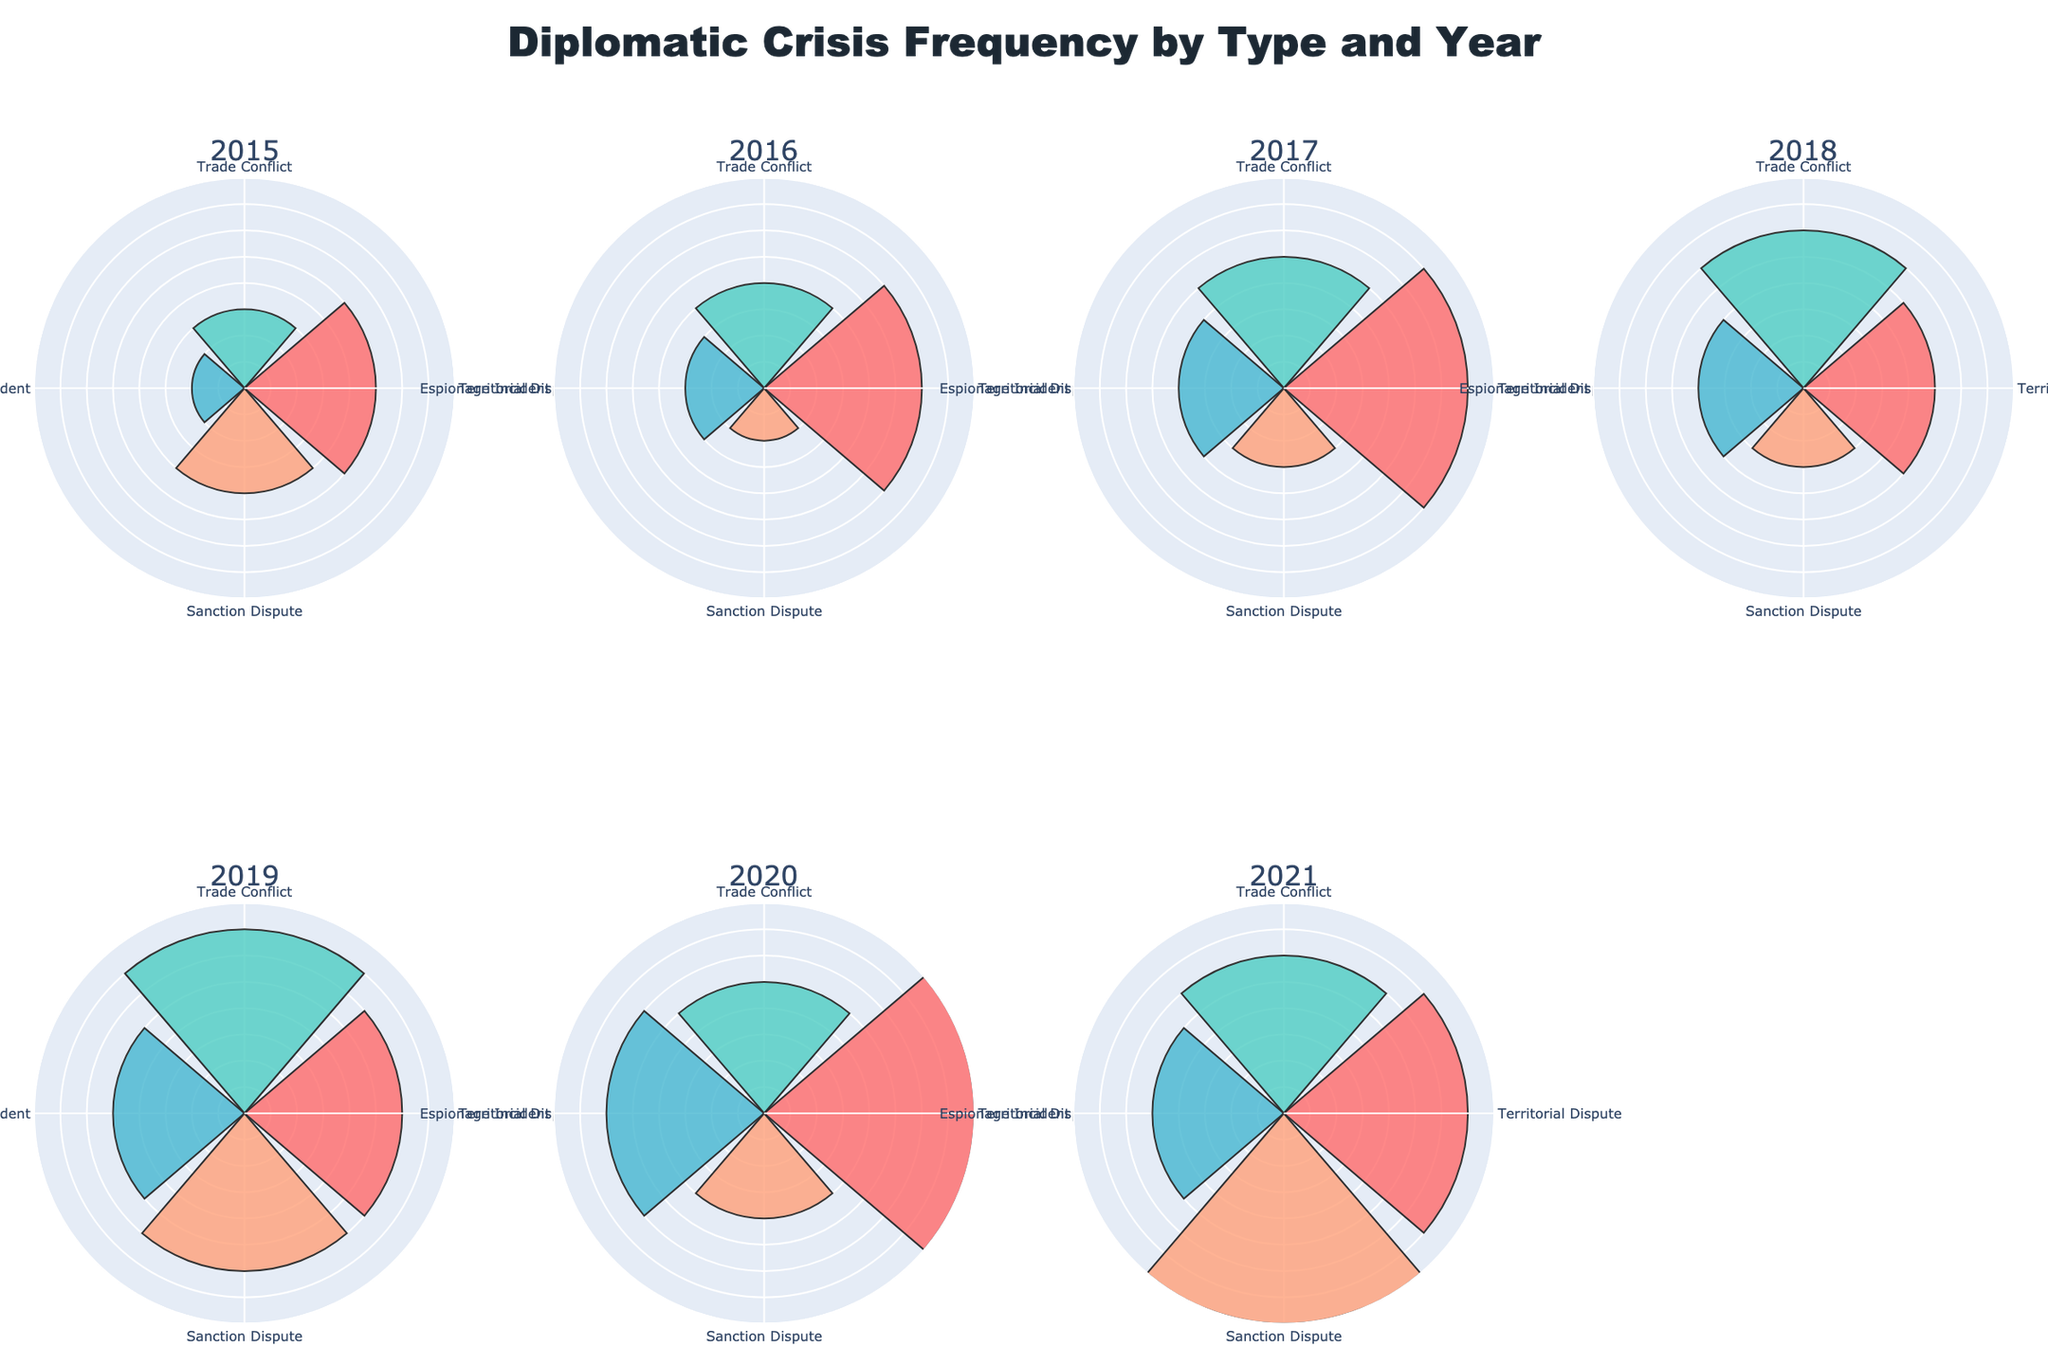What's the title of the figure? The title is prominently displayed at the top of the figure. It summarises what the figure represents.
Answer: Diplomatic Crisis Frequency by Type and Year How many subplots are present in the figure? The figure title suggests it shows data for multiple years, and the plot layout indicates a matrix of subplots.
Answer: 8 Which year had the highest frequency of Territorial Disputes? By examining the size of the bars under "Territorial Dispute" category across all years, the highest bar indicates the maximum frequency.
Answer: 2020 Which type of crisis had the lowest frequency in 2017? Look at the subplot for 2017 and compare the lengths of the bars for different crisis types to find the shortest.
Answer: Sanction Dispute Compare the frequency of Trade Conflicts between 2016 and 2018. Which year had a higher frequency? Locate the subplots for 2016 and 2018, and compare the bars under "Trade Conflict". 2018 has a higher bar visually.
Answer: 2018 In which year did Espionage Incidents increase compared to the previous year? Track the bars for "Espionage Incident" across consecutive subplots and identify years where the bar height increases.
Answer: Multiple years can be identified, but 2018 to 2019 is one instance What's the average frequency of Trade Conflicts from 2015 to 2017? Sum the bar heights for "Trade Conflict" from 2015, 2016, and 2017, then divide by 3. Calculation: (3 + 4 + 5) / 3 = 12 / 3.
Answer: 4 Which type of crisis showed the most consistent frequency levels from 2015 to 2021? Visually inspecting all subplots, the crisis type with bars of similar height across years demonstrates consistency.
Answer: Espionage Incident How did the frequency of Sanction Disputes change from 2019 to 2021? Analyze the height of the bars for Sanction Dispute in 2019, 2020, and 2021. Notice the change in height. Calculation: 6 to 4 to 8.
Answer: Decreased then increased 